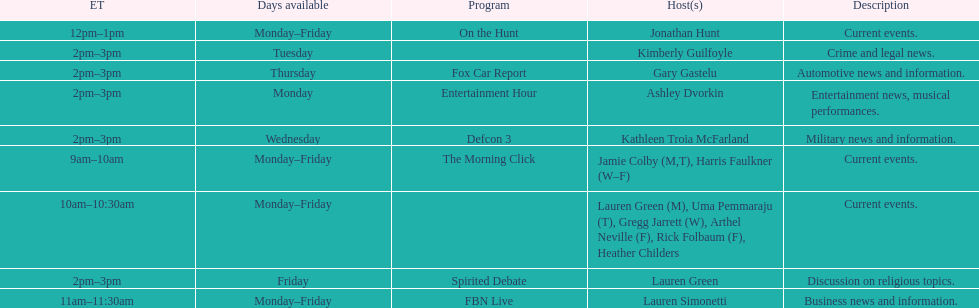Which program is only available on thursdays? Fox Car Report. 